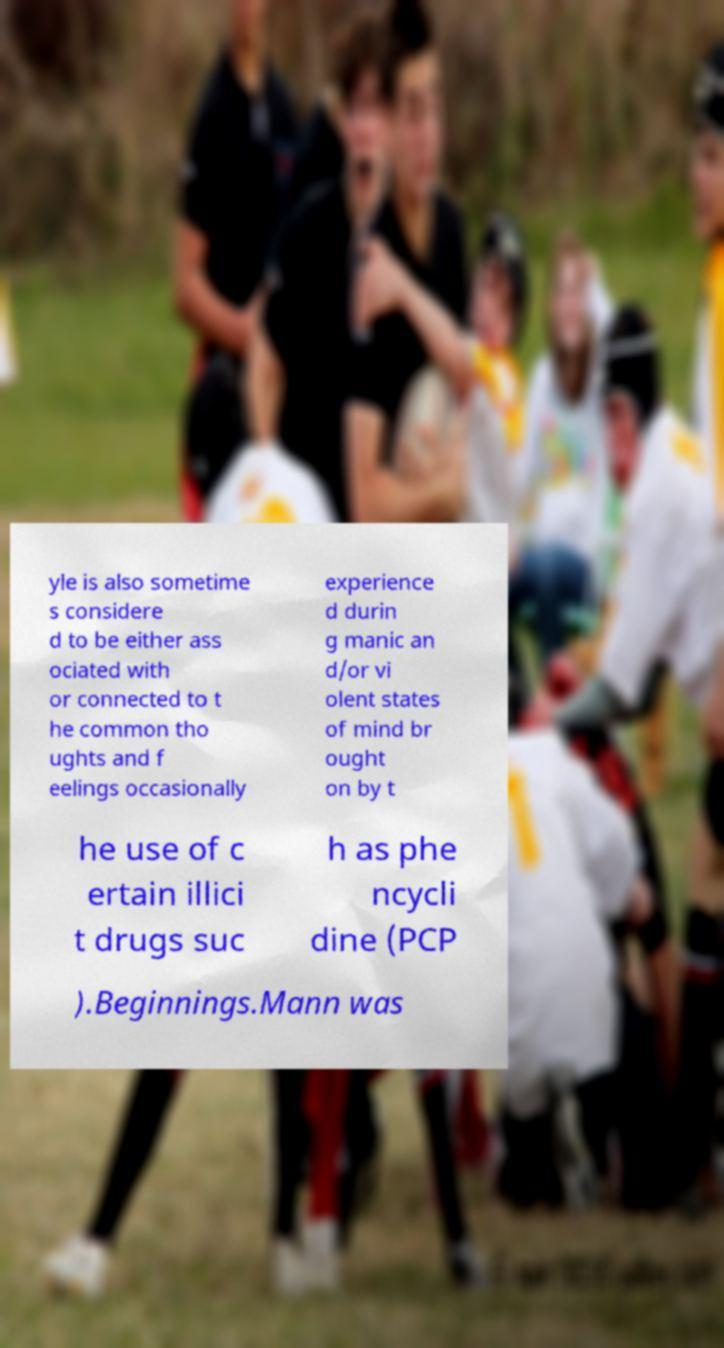There's text embedded in this image that I need extracted. Can you transcribe it verbatim? yle is also sometime s considere d to be either ass ociated with or connected to t he common tho ughts and f eelings occasionally experience d durin g manic an d/or vi olent states of mind br ought on by t he use of c ertain illici t drugs suc h as phe ncycli dine (PCP ).Beginnings.Mann was 